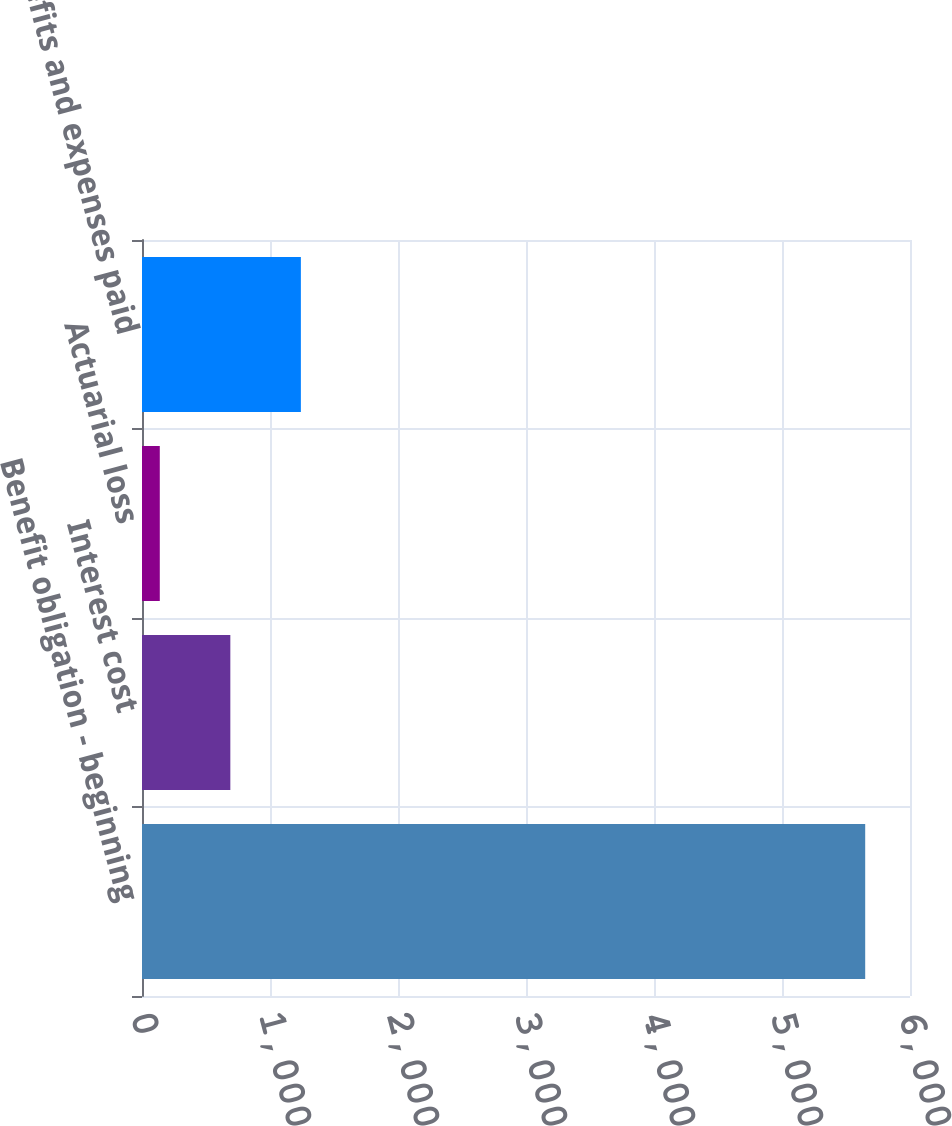Convert chart. <chart><loc_0><loc_0><loc_500><loc_500><bar_chart><fcel>Benefit obligation - beginning<fcel>Interest cost<fcel>Actuarial loss<fcel>Benefits and expenses paid<nl><fcel>5650<fcel>690.1<fcel>139<fcel>1241.2<nl></chart> 